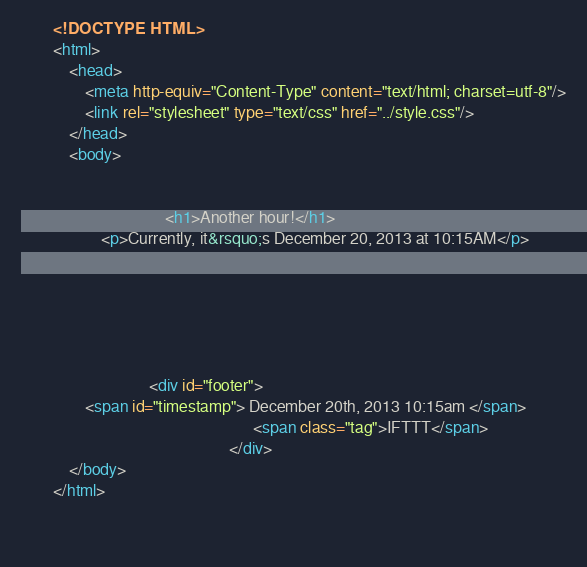Convert code to text. <code><loc_0><loc_0><loc_500><loc_500><_HTML_>        <!DOCTYPE HTML>
        <html>
            <head>
                <meta http-equiv="Content-Type" content="text/html; charset=utf-8"/>
                <link rel="stylesheet" type="text/css" href="../style.css"/>
            </head>
            <body>
                
                
                                    <h1>Another hour!</h1>
                    <p>Currently, it&rsquo;s December 20, 2013 at 10:15AM</p>
                
                
                
                
                
                
                                <div id="footer">
                <span id="timestamp"> December 20th, 2013 10:15am </span>
                                                          <span class="tag">IFTTT</span>
                                                    </div>
            </body>
        </html>

        </code> 